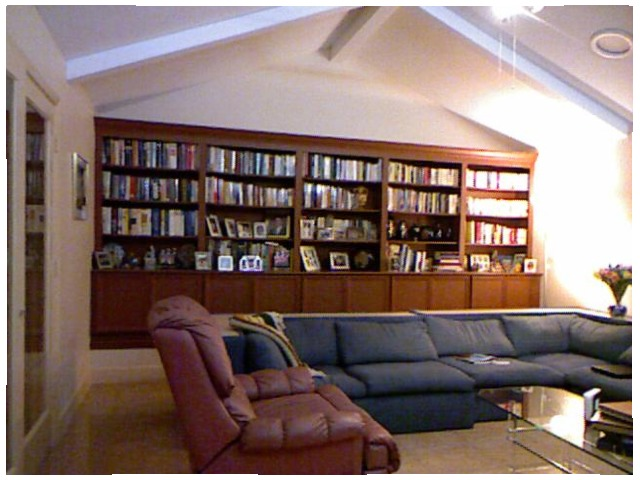<image>
Is the books in the shelf? Yes. The books is contained within or inside the shelf, showing a containment relationship. 